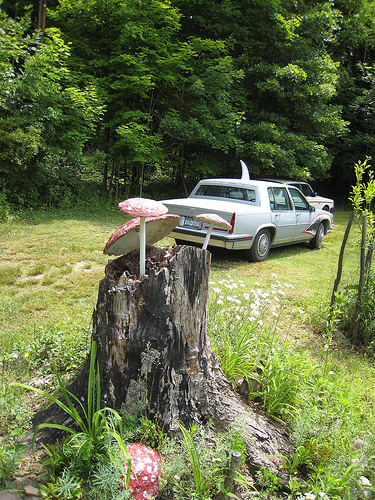<image>
Is the car in front of the tree stump? No. The car is not in front of the tree stump. The spatial positioning shows a different relationship between these objects. 